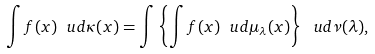Convert formula to latex. <formula><loc_0><loc_0><loc_500><loc_500>\int f ( x ) \ u d \kappa ( x ) = \int \left \{ \int f ( x ) \ u d \mu _ { \lambda } ( x ) \right \} \ u d \nu ( \lambda ) ,</formula> 